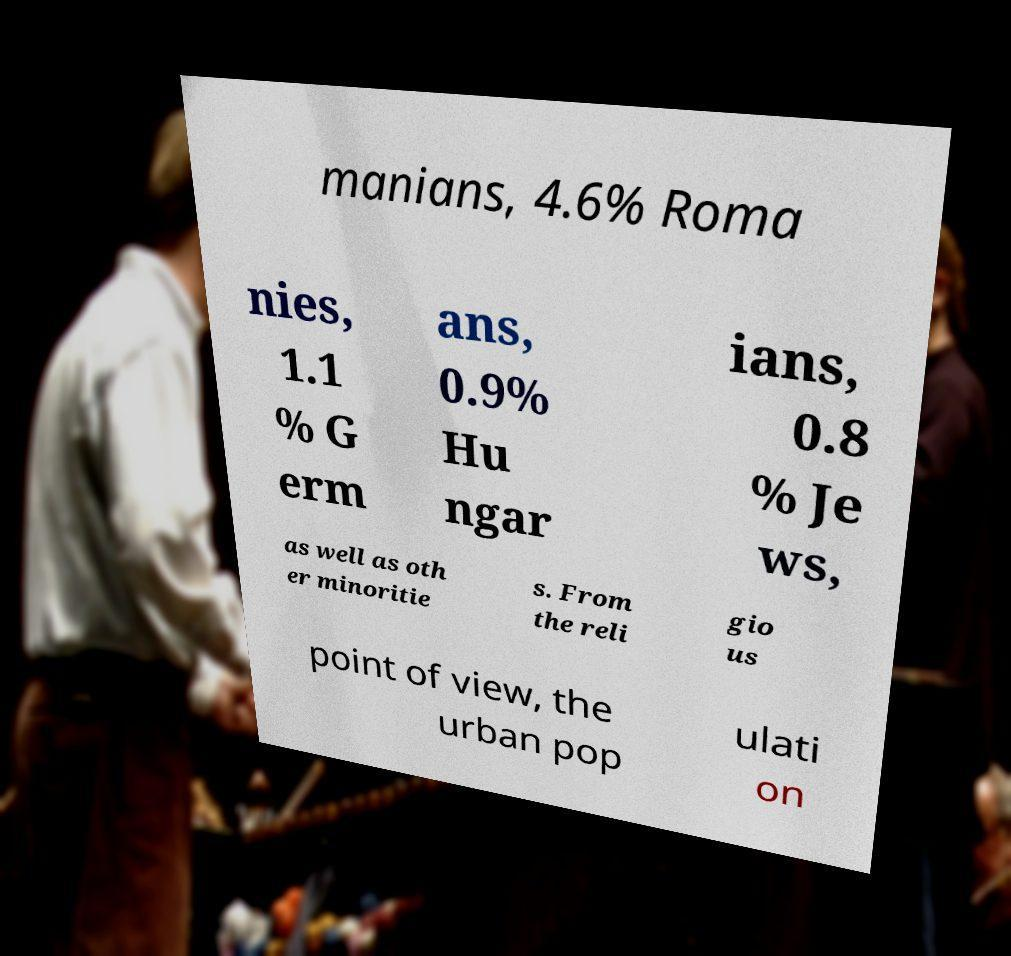Could you assist in decoding the text presented in this image and type it out clearly? manians, 4.6% Roma nies, 1.1 % G erm ans, 0.9% Hu ngar ians, 0.8 % Je ws, as well as oth er minoritie s. From the reli gio us point of view, the urban pop ulati on 